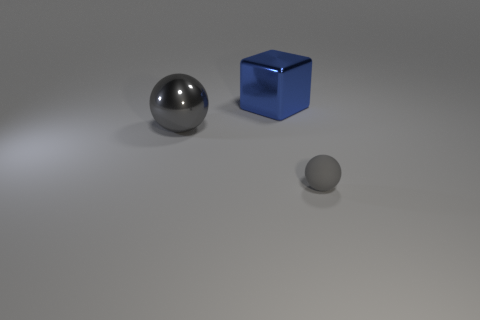Is there any other thing that is the same size as the gray matte sphere?
Give a very brief answer. No. What shape is the other large thing that is the same color as the rubber object?
Offer a very short reply. Sphere. How many balls are the same size as the blue block?
Ensure brevity in your answer.  1. How many things are either gray balls to the right of the large gray metal object or objects left of the gray rubber sphere?
Ensure brevity in your answer.  3. Is the gray object that is in front of the gray metallic object made of the same material as the thing behind the large sphere?
Provide a short and direct response. No. What shape is the large blue metal object that is behind the object that is in front of the big gray sphere?
Keep it short and to the point. Cube. Are there any other things that have the same color as the tiny ball?
Offer a very short reply. Yes. Is there a big cube that is to the left of the gray thing that is in front of the gray ball on the left side of the big blue shiny thing?
Provide a succinct answer. Yes. Is the color of the metal thing in front of the blue thing the same as the tiny matte ball on the right side of the large blue cube?
Keep it short and to the point. Yes. What size is the gray object in front of the ball that is behind the gray object right of the blue metal block?
Provide a short and direct response. Small. 